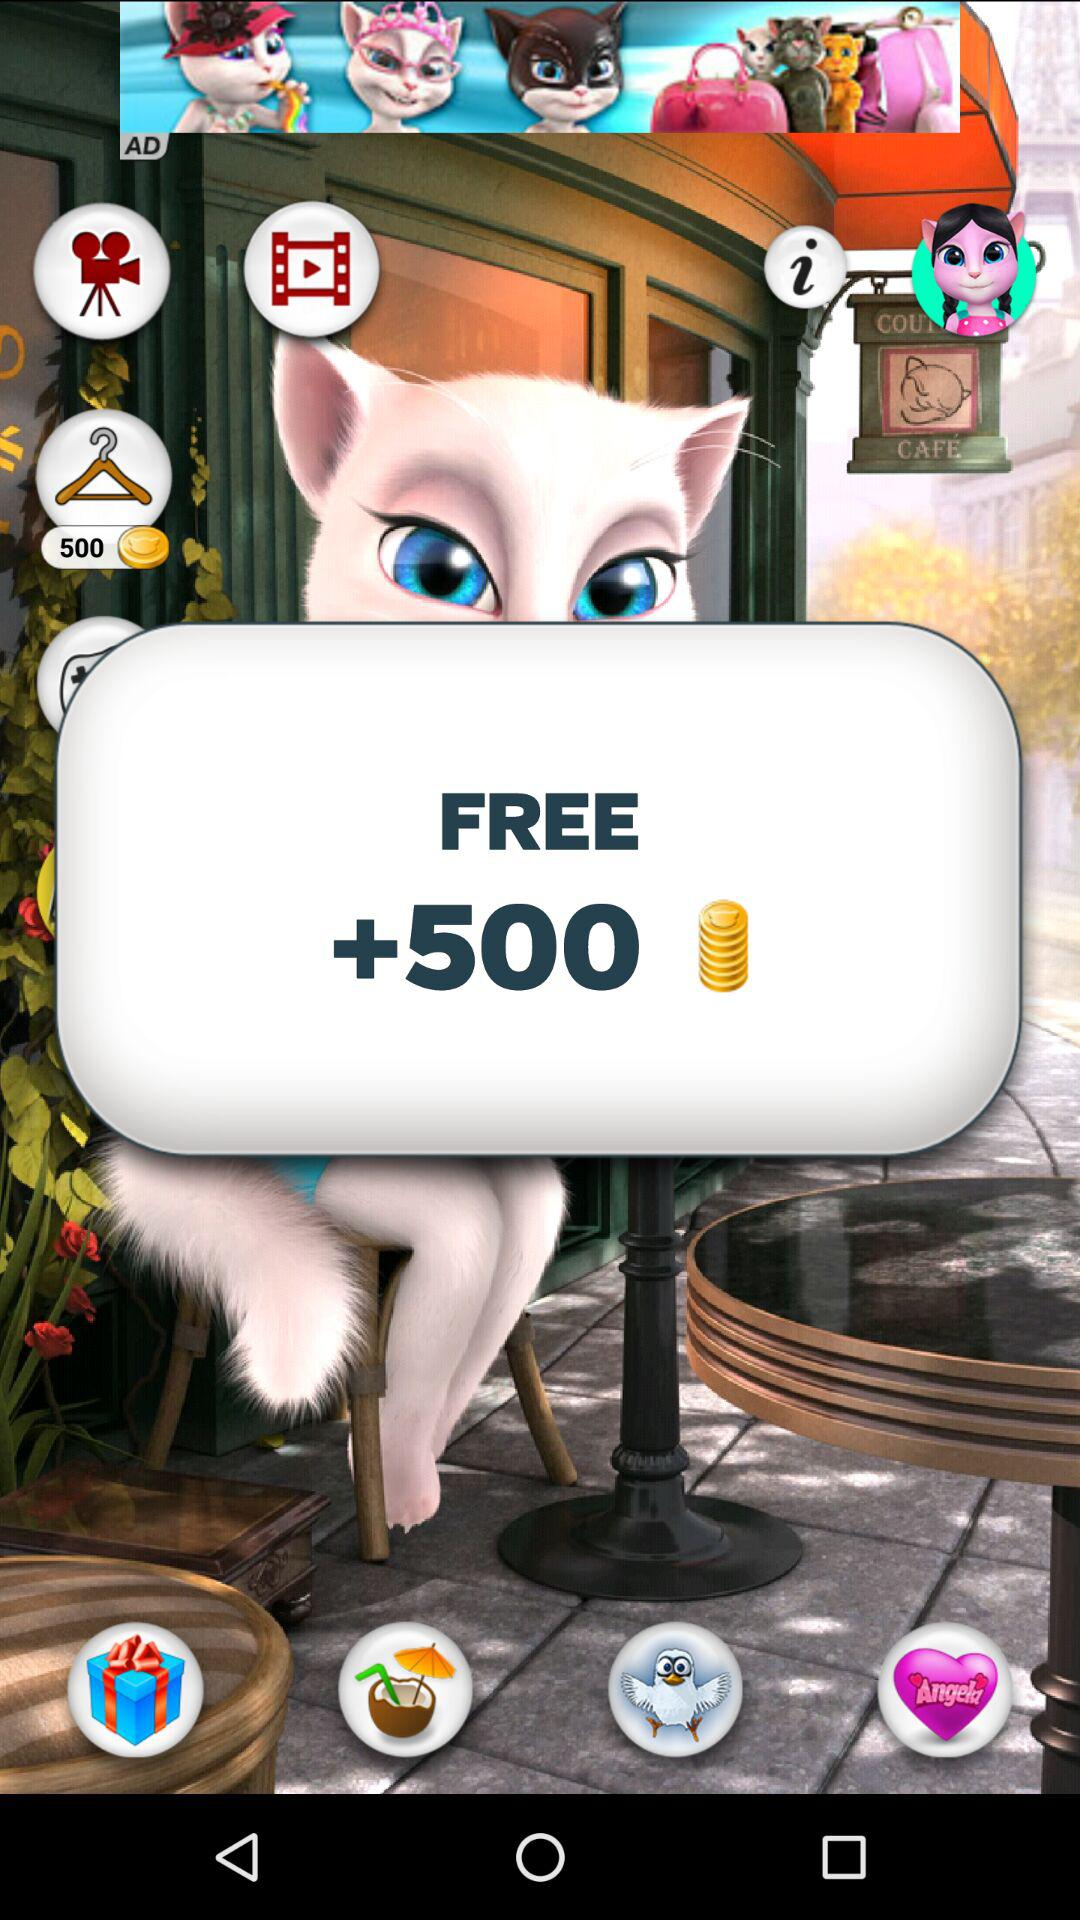How many more coins are there than the amount of money?
Answer the question using a single word or phrase. 500 